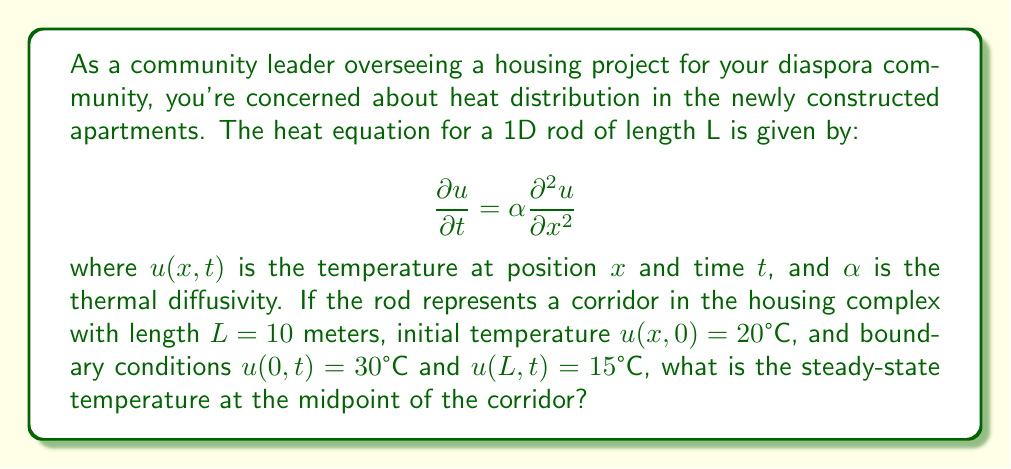Help me with this question. To solve this problem, we need to follow these steps:

1) For the steady-state solution, the temperature doesn't change with time. So, we set $\frac{\partial u}{\partial t} = 0$ in the heat equation:

   $$0 = \alpha \frac{\partial^2 u}{\partial x^2}$$

2) This simplifies to:

   $$\frac{d^2u}{dx^2} = 0$$

3) The general solution to this equation is:

   $$u(x) = Ax + B$$

   where A and B are constants we need to determine.

4) We use the boundary conditions to find A and B:
   
   At $x = 0$: $u(0) = 30 = B$
   At $x = L = 10$: $u(10) = 15 = 10A + 30$

5) From the second condition:
   
   $$15 = 10A + 30$$
   $$-15 = 10A$$
   $$A = -1.5$$

6) So our steady-state solution is:

   $$u(x) = -1.5x + 30$$

7) The midpoint of the corridor is at $x = L/2 = 5$ meters. To find the temperature here, we substitute this into our solution:

   $$u(5) = -1.5(5) + 30 = -7.5 + 30 = 22.5$$

Therefore, the steady-state temperature at the midpoint of the corridor is 22.5°C.
Answer: 22.5°C 